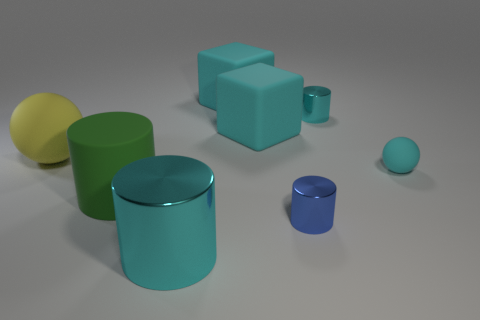There is a large cyan thing behind the small cyan metal cylinder; what is its shape?
Provide a short and direct response. Cube. There is another object that is the same shape as the yellow object; what is its size?
Offer a terse response. Small. There is a tiny shiny thing that is behind the rubber ball right of the yellow ball; what number of cyan things are in front of it?
Make the answer very short. 3. Are there an equal number of yellow rubber balls in front of the small cyan matte thing and large purple rubber cylinders?
Offer a very short reply. Yes. What number of balls are large metallic things or tiny rubber things?
Make the answer very short. 1. Is the color of the tiny matte thing the same as the large matte ball?
Provide a short and direct response. No. Are there an equal number of cylinders that are in front of the tiny cyan matte object and big green objects that are right of the tiny blue metal thing?
Provide a short and direct response. No. The tiny sphere has what color?
Keep it short and to the point. Cyan. How many things are matte objects that are to the left of the big green object or small gray metallic spheres?
Offer a terse response. 1. There is a rubber ball left of the tiny cyan cylinder; does it have the same size as the cyan object in front of the small cyan matte ball?
Your answer should be very brief. Yes. 